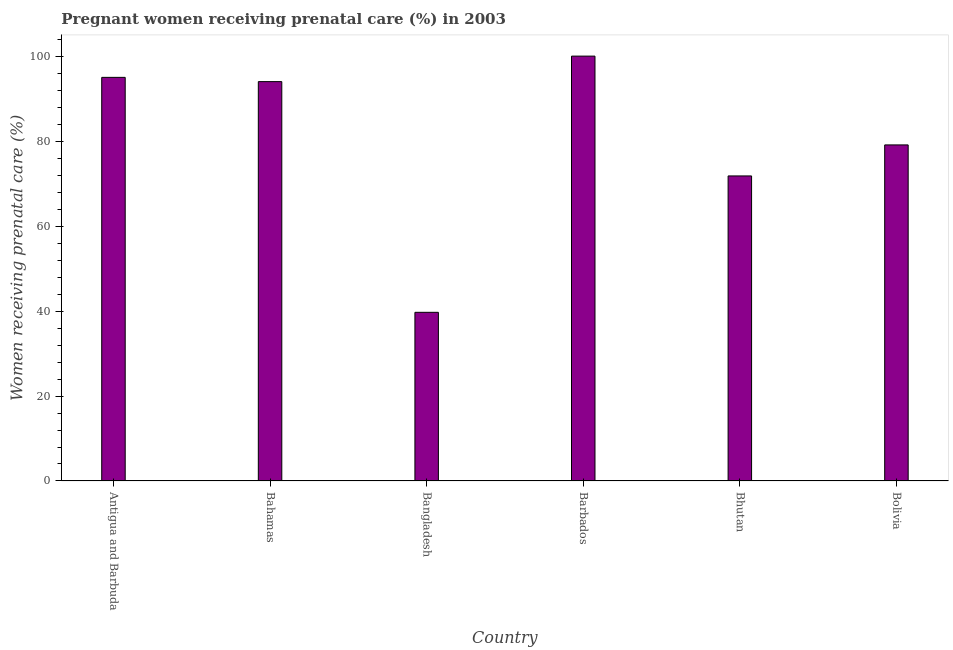What is the title of the graph?
Your answer should be very brief. Pregnant women receiving prenatal care (%) in 2003. What is the label or title of the Y-axis?
Provide a succinct answer. Women receiving prenatal care (%). What is the percentage of pregnant women receiving prenatal care in Bhutan?
Offer a terse response. 71.8. Across all countries, what is the maximum percentage of pregnant women receiving prenatal care?
Keep it short and to the point. 100. Across all countries, what is the minimum percentage of pregnant women receiving prenatal care?
Provide a short and direct response. 39.7. In which country was the percentage of pregnant women receiving prenatal care maximum?
Offer a terse response. Barbados. What is the sum of the percentage of pregnant women receiving prenatal care?
Make the answer very short. 479.6. What is the difference between the percentage of pregnant women receiving prenatal care in Antigua and Barbuda and Bangladesh?
Make the answer very short. 55.3. What is the average percentage of pregnant women receiving prenatal care per country?
Your response must be concise. 79.93. What is the median percentage of pregnant women receiving prenatal care?
Offer a terse response. 86.55. In how many countries, is the percentage of pregnant women receiving prenatal care greater than 8 %?
Your answer should be compact. 6. What is the ratio of the percentage of pregnant women receiving prenatal care in Bahamas to that in Bolivia?
Give a very brief answer. 1.19. Is the sum of the percentage of pregnant women receiving prenatal care in Antigua and Barbuda and Bhutan greater than the maximum percentage of pregnant women receiving prenatal care across all countries?
Your answer should be compact. Yes. What is the difference between the highest and the lowest percentage of pregnant women receiving prenatal care?
Your answer should be compact. 60.3. How many bars are there?
Give a very brief answer. 6. What is the Women receiving prenatal care (%) of Antigua and Barbuda?
Keep it short and to the point. 95. What is the Women receiving prenatal care (%) in Bahamas?
Keep it short and to the point. 94. What is the Women receiving prenatal care (%) in Bangladesh?
Offer a very short reply. 39.7. What is the Women receiving prenatal care (%) of Bhutan?
Ensure brevity in your answer.  71.8. What is the Women receiving prenatal care (%) of Bolivia?
Provide a succinct answer. 79.1. What is the difference between the Women receiving prenatal care (%) in Antigua and Barbuda and Bahamas?
Make the answer very short. 1. What is the difference between the Women receiving prenatal care (%) in Antigua and Barbuda and Bangladesh?
Offer a terse response. 55.3. What is the difference between the Women receiving prenatal care (%) in Antigua and Barbuda and Barbados?
Offer a very short reply. -5. What is the difference between the Women receiving prenatal care (%) in Antigua and Barbuda and Bhutan?
Give a very brief answer. 23.2. What is the difference between the Women receiving prenatal care (%) in Antigua and Barbuda and Bolivia?
Give a very brief answer. 15.9. What is the difference between the Women receiving prenatal care (%) in Bahamas and Bangladesh?
Provide a short and direct response. 54.3. What is the difference between the Women receiving prenatal care (%) in Bahamas and Barbados?
Offer a very short reply. -6. What is the difference between the Women receiving prenatal care (%) in Bahamas and Bhutan?
Your response must be concise. 22.2. What is the difference between the Women receiving prenatal care (%) in Bangladesh and Barbados?
Your response must be concise. -60.3. What is the difference between the Women receiving prenatal care (%) in Bangladesh and Bhutan?
Your answer should be very brief. -32.1. What is the difference between the Women receiving prenatal care (%) in Bangladesh and Bolivia?
Ensure brevity in your answer.  -39.4. What is the difference between the Women receiving prenatal care (%) in Barbados and Bhutan?
Provide a succinct answer. 28.2. What is the difference between the Women receiving prenatal care (%) in Barbados and Bolivia?
Give a very brief answer. 20.9. What is the difference between the Women receiving prenatal care (%) in Bhutan and Bolivia?
Offer a very short reply. -7.3. What is the ratio of the Women receiving prenatal care (%) in Antigua and Barbuda to that in Bangladesh?
Provide a short and direct response. 2.39. What is the ratio of the Women receiving prenatal care (%) in Antigua and Barbuda to that in Barbados?
Your response must be concise. 0.95. What is the ratio of the Women receiving prenatal care (%) in Antigua and Barbuda to that in Bhutan?
Your response must be concise. 1.32. What is the ratio of the Women receiving prenatal care (%) in Antigua and Barbuda to that in Bolivia?
Make the answer very short. 1.2. What is the ratio of the Women receiving prenatal care (%) in Bahamas to that in Bangladesh?
Ensure brevity in your answer.  2.37. What is the ratio of the Women receiving prenatal care (%) in Bahamas to that in Barbados?
Ensure brevity in your answer.  0.94. What is the ratio of the Women receiving prenatal care (%) in Bahamas to that in Bhutan?
Your answer should be compact. 1.31. What is the ratio of the Women receiving prenatal care (%) in Bahamas to that in Bolivia?
Offer a terse response. 1.19. What is the ratio of the Women receiving prenatal care (%) in Bangladesh to that in Barbados?
Your response must be concise. 0.4. What is the ratio of the Women receiving prenatal care (%) in Bangladesh to that in Bhutan?
Give a very brief answer. 0.55. What is the ratio of the Women receiving prenatal care (%) in Bangladesh to that in Bolivia?
Your response must be concise. 0.5. What is the ratio of the Women receiving prenatal care (%) in Barbados to that in Bhutan?
Make the answer very short. 1.39. What is the ratio of the Women receiving prenatal care (%) in Barbados to that in Bolivia?
Ensure brevity in your answer.  1.26. What is the ratio of the Women receiving prenatal care (%) in Bhutan to that in Bolivia?
Provide a short and direct response. 0.91. 